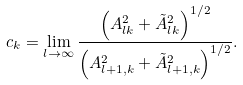<formula> <loc_0><loc_0><loc_500><loc_500>c _ { k } = \lim _ { l \rightarrow \infty } \frac { \left ( A _ { l k } ^ { 2 } + \tilde { A } _ { l k } ^ { 2 } \right ) ^ { 1 / 2 } } { \left ( A _ { l + 1 , k } ^ { 2 } + \tilde { A } _ { l + 1 , k } ^ { 2 } \right ) ^ { 1 / 2 } } .</formula> 